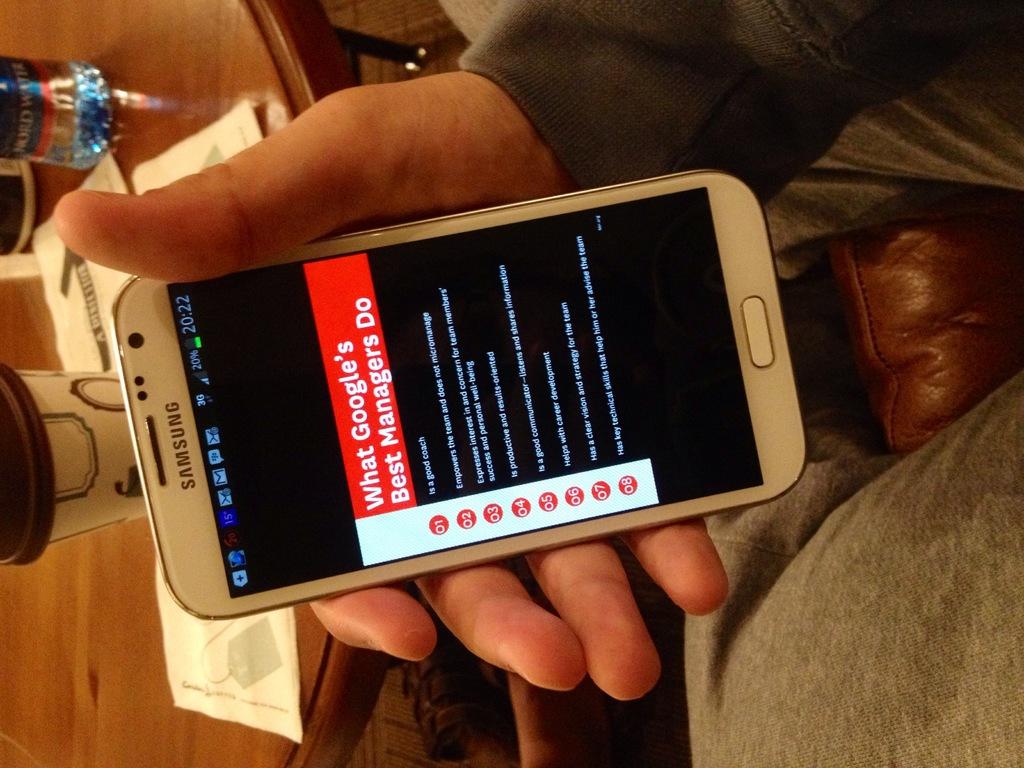What brand of phone?
Provide a short and direct response. Samsung. 